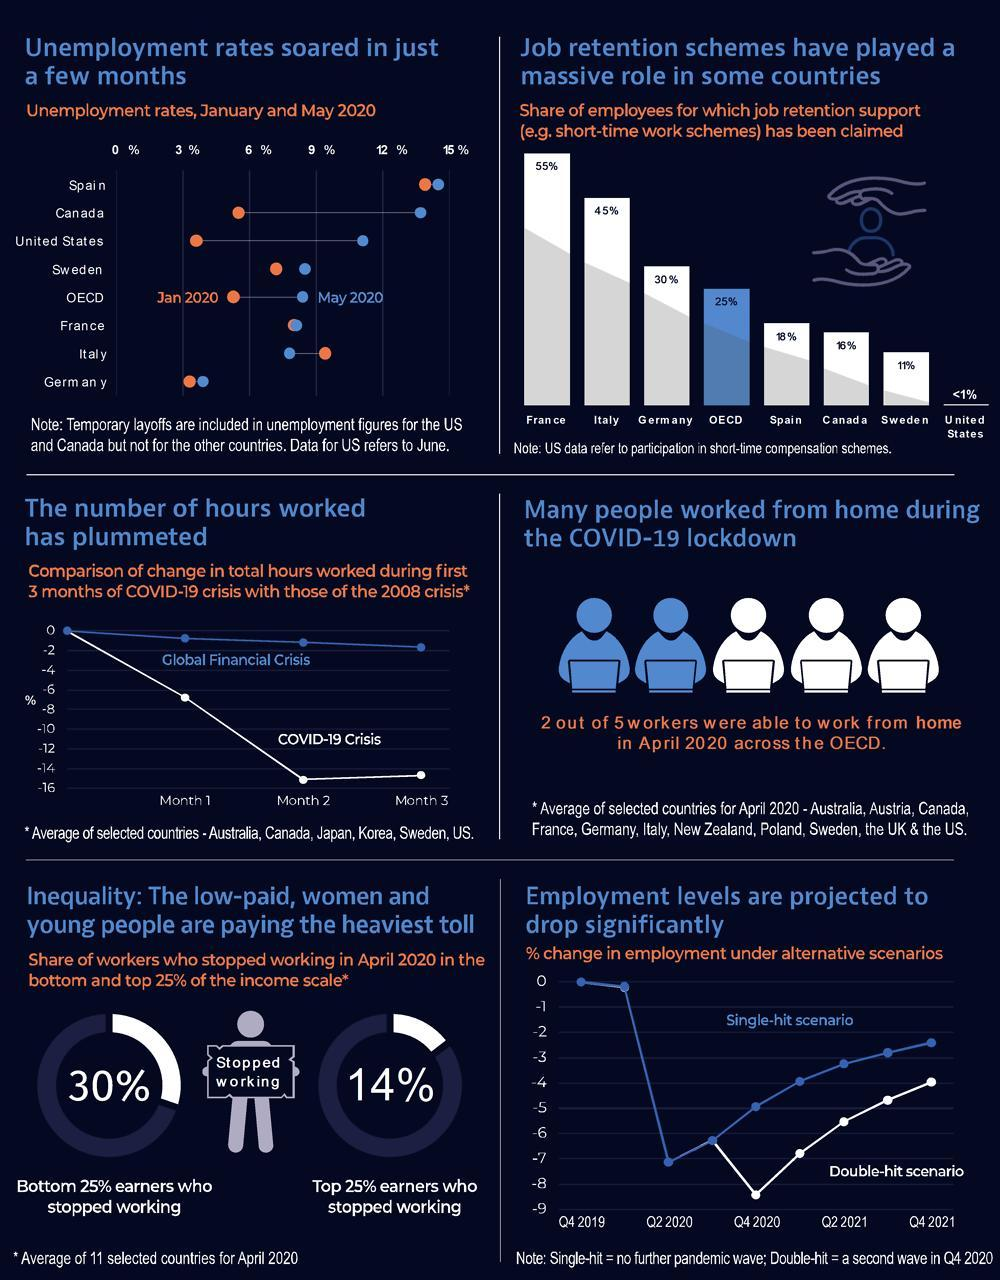What is the share of employees in Spain who had claimed their job retention support?
Answer the question with a short phrase. 18% Which country has reported an unemployment rate greater than 12% in May 2020? Spain Which country has reported an unemployment rate between 3-6% in May 2020? Germany Which country has reported an unemployment rate greater than 12% in January 2020? Spain What is the share of workers who had stopped working in April 2020 in the top 25% of the income scale? 14% What is the share of workers who had stopped working in April 2020 in the bottom 25% of the income scale? 30% What is the share of employees in France who had claimed their job retention support? 55% Which country has reported an unemployment rate between 9-12% in January 2020? Italy 